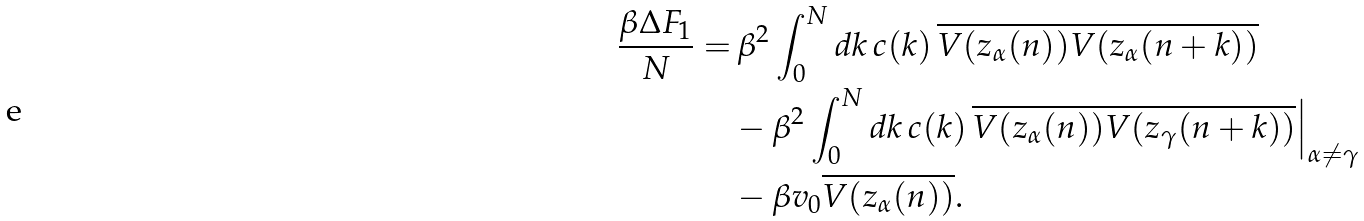<formula> <loc_0><loc_0><loc_500><loc_500>\frac { \beta \Delta F _ { 1 } } { N } = & \, \beta ^ { 2 } \int _ { 0 } ^ { N } d k \, c ( k ) \, \overline { V ( z _ { \alpha } ( n ) ) V ( z _ { \alpha } ( n + k ) ) } \\ & - \beta ^ { 2 } \int _ { 0 } ^ { N } d k \, c ( k ) \, \overline { V ( z _ { \alpha } ( n ) ) V ( z _ { \gamma } ( n + k ) ) } \Big | _ { \alpha \ne \gamma } \\ & - \beta v _ { 0 } \overline { V ( z _ { \alpha } ( n ) ) } .</formula> 